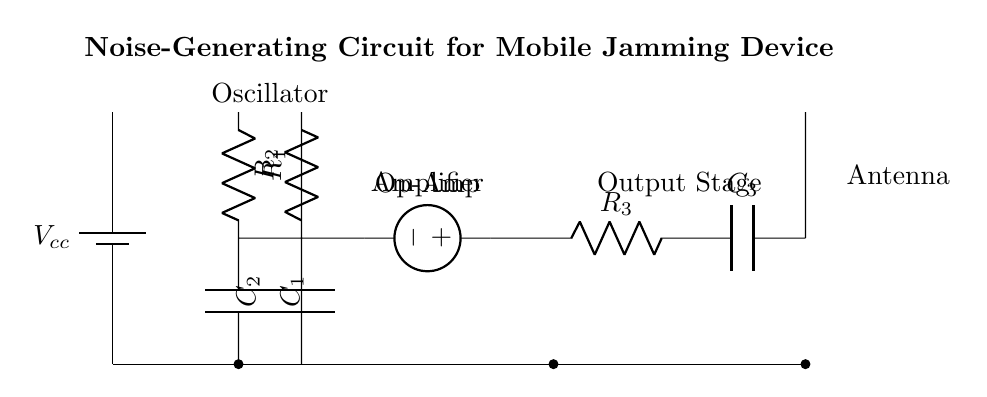What is the main function of this circuit? The circuit is designed to generate noise for jamming mobile communications to prevent eavesdropping. This can be inferred from the title and the presence of components that would create oscillations and amplify signals.
Answer: Noise generation What type of component is used for the oscillator? The oscillator consists of a resistor and a capacitor arranged in a feedback circuit that generates oscillations. This is typical in generating varying signals for jamming purposes.
Answer: Resistor and capacitor How many resistors are present in the circuit? There are three resistors, indicated by the labels R1, R2, and R3 in the circuit diagram. Each resistor has a role in controlling current and voltage in the circuit.
Answer: Three What is the role of the amplifier in this circuit? The amplifier takes the weak signal generated by the oscillator and boosts it to a level that can be transmitted through the antenna. This is represented by the Op-Amp symbol in the circuit.
Answer: Signal boosting What is the output component of this jamming device? The output component is the antenna, which is essential for emitting the generated noise to interfere with potential eavesdroppers in communication. This is located at the output stage of the circuit.
Answer: Antenna Which capacitors are used in the circuit? There are three capacitors labeled as C1, C2, and C3. Each capacitor is used at different stages of the circuit, indicated by their respective positions.
Answer: C1, C2, C3 What is the function of the battery in this circuit? The battery provides the necessary voltage supply for the entire circuit operation, as shown at the beginning of the diagram. It ensures all components receive power to function.
Answer: Power supply 